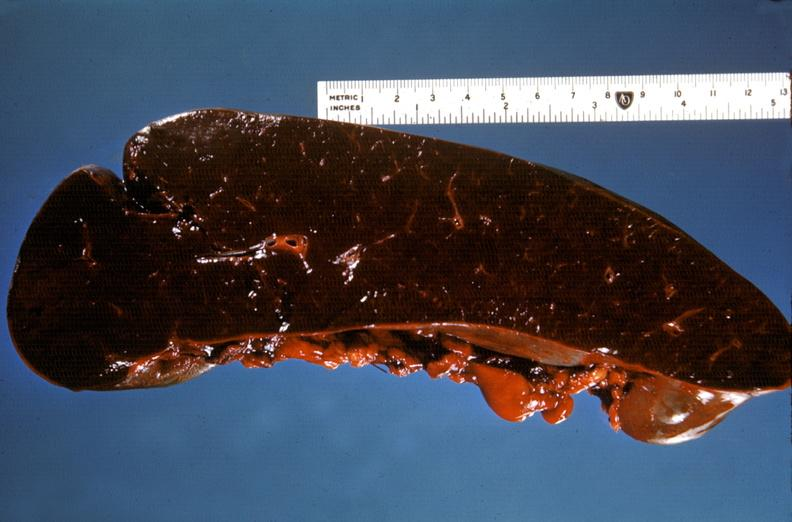does mixed mesodermal tumor show spleen, hypersplenism?
Answer the question using a single word or phrase. No 